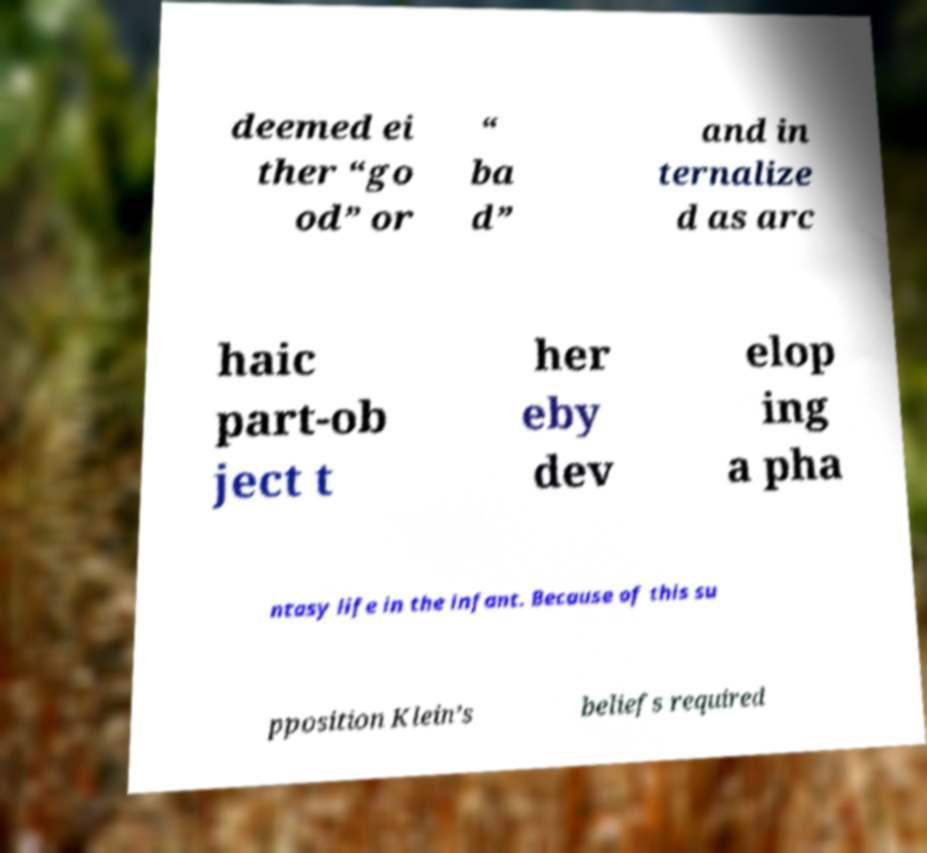Could you assist in decoding the text presented in this image and type it out clearly? deemed ei ther “go od” or “ ba d” and in ternalize d as arc haic part-ob ject t her eby dev elop ing a pha ntasy life in the infant. Because of this su pposition Klein’s beliefs required 